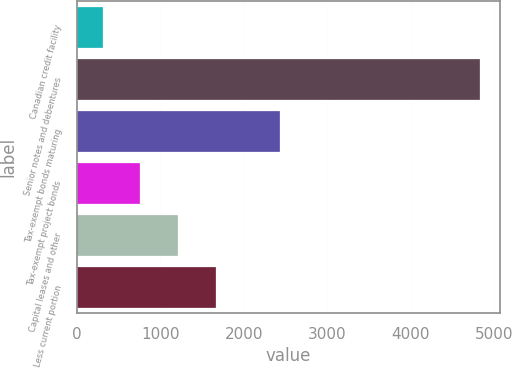Convert chart. <chart><loc_0><loc_0><loc_500><loc_500><bar_chart><fcel>Canadian credit facility<fcel>Senior notes and debentures<fcel>Tax-exempt bonds maturing<fcel>Tax-exempt project bonds<fcel>Capital leases and other<fcel>Less current portion<nl><fcel>308<fcel>4829<fcel>2440<fcel>760.1<fcel>1212.2<fcel>1664.3<nl></chart> 